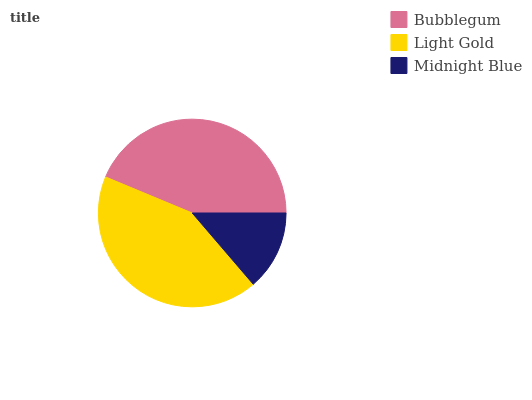Is Midnight Blue the minimum?
Answer yes or no. Yes. Is Bubblegum the maximum?
Answer yes or no. Yes. Is Light Gold the minimum?
Answer yes or no. No. Is Light Gold the maximum?
Answer yes or no. No. Is Bubblegum greater than Light Gold?
Answer yes or no. Yes. Is Light Gold less than Bubblegum?
Answer yes or no. Yes. Is Light Gold greater than Bubblegum?
Answer yes or no. No. Is Bubblegum less than Light Gold?
Answer yes or no. No. Is Light Gold the high median?
Answer yes or no. Yes. Is Light Gold the low median?
Answer yes or no. Yes. Is Bubblegum the high median?
Answer yes or no. No. Is Bubblegum the low median?
Answer yes or no. No. 